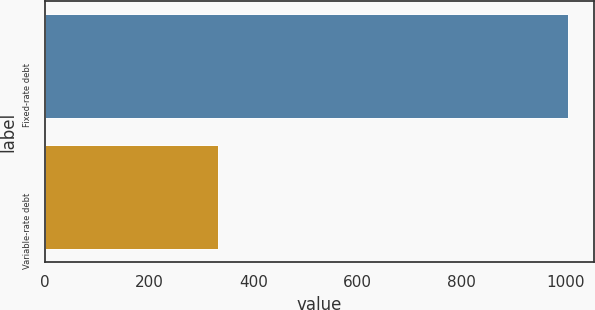Convert chart. <chart><loc_0><loc_0><loc_500><loc_500><bar_chart><fcel>Fixed-rate debt<fcel>Variable-rate debt<nl><fcel>1005<fcel>333<nl></chart> 